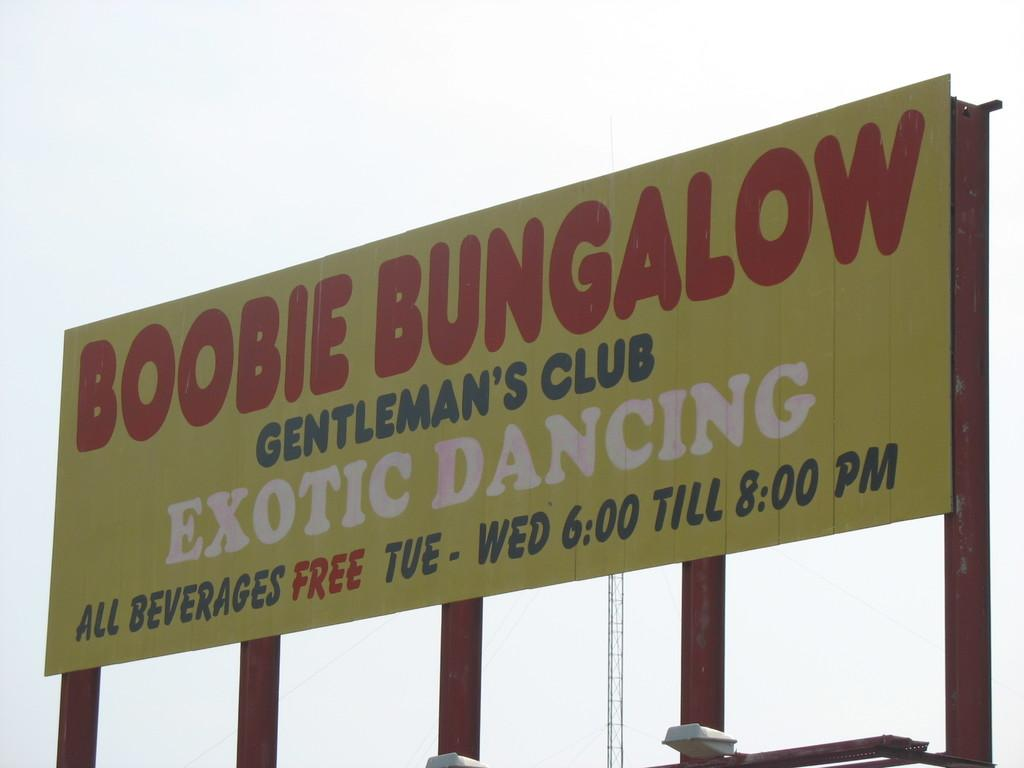<image>
Describe the image concisely. The club advertised offers free drinks on a Tuesday and Wednesday at certain times. 